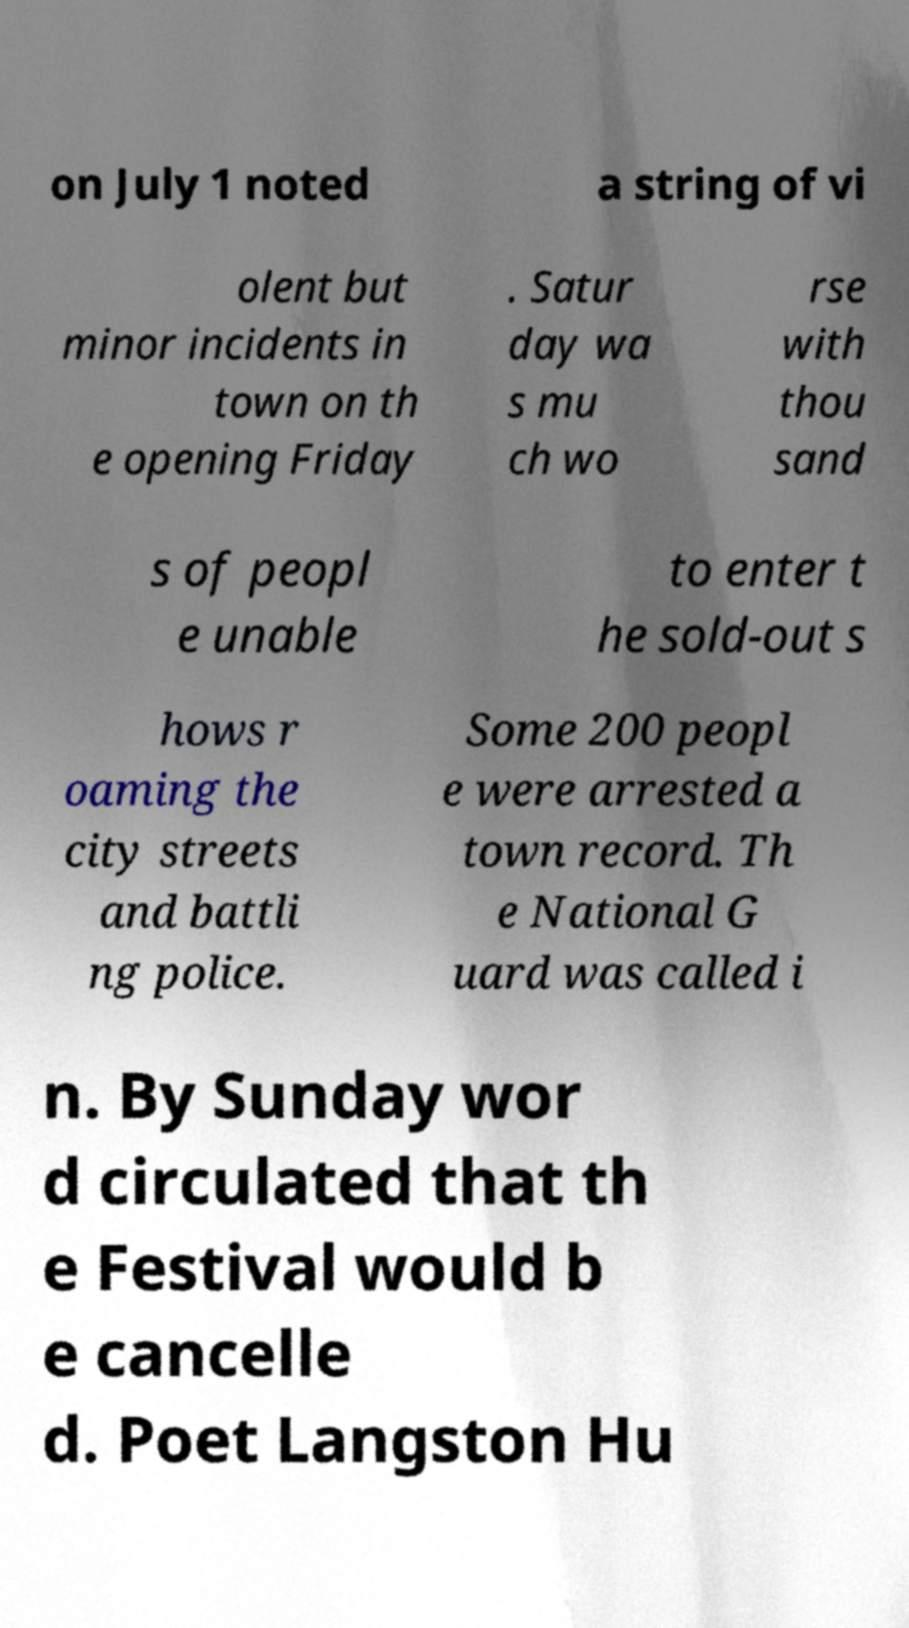There's text embedded in this image that I need extracted. Can you transcribe it verbatim? on July 1 noted a string of vi olent but minor incidents in town on th e opening Friday . Satur day wa s mu ch wo rse with thou sand s of peopl e unable to enter t he sold-out s hows r oaming the city streets and battli ng police. Some 200 peopl e were arrested a town record. Th e National G uard was called i n. By Sunday wor d circulated that th e Festival would b e cancelle d. Poet Langston Hu 